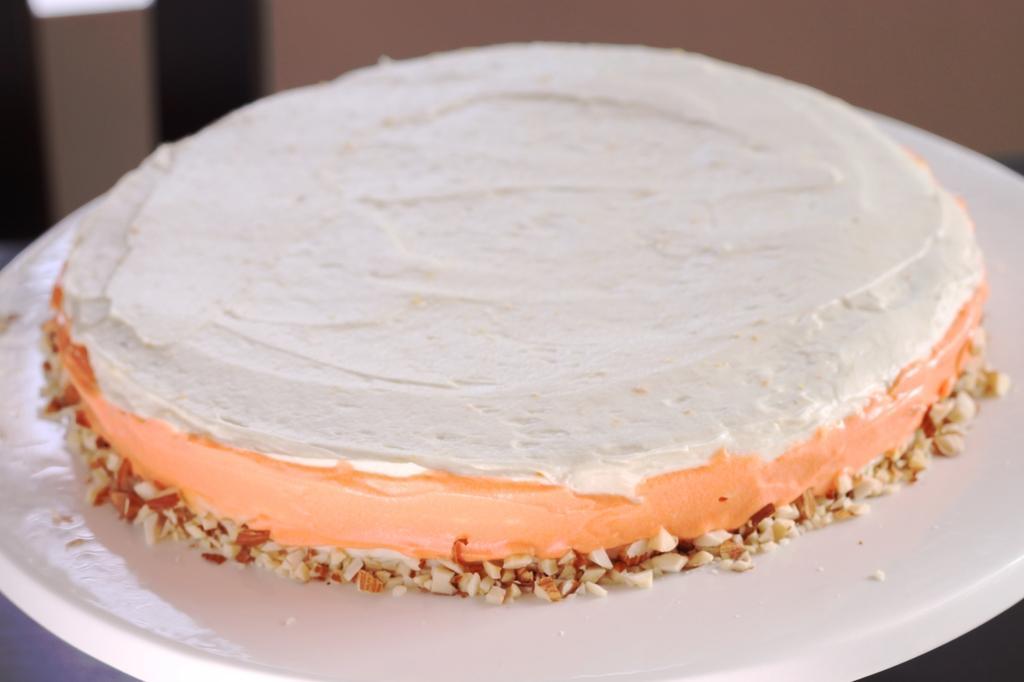Please provide a concise description of this image. This picture looks like a cake on the cake stand. 